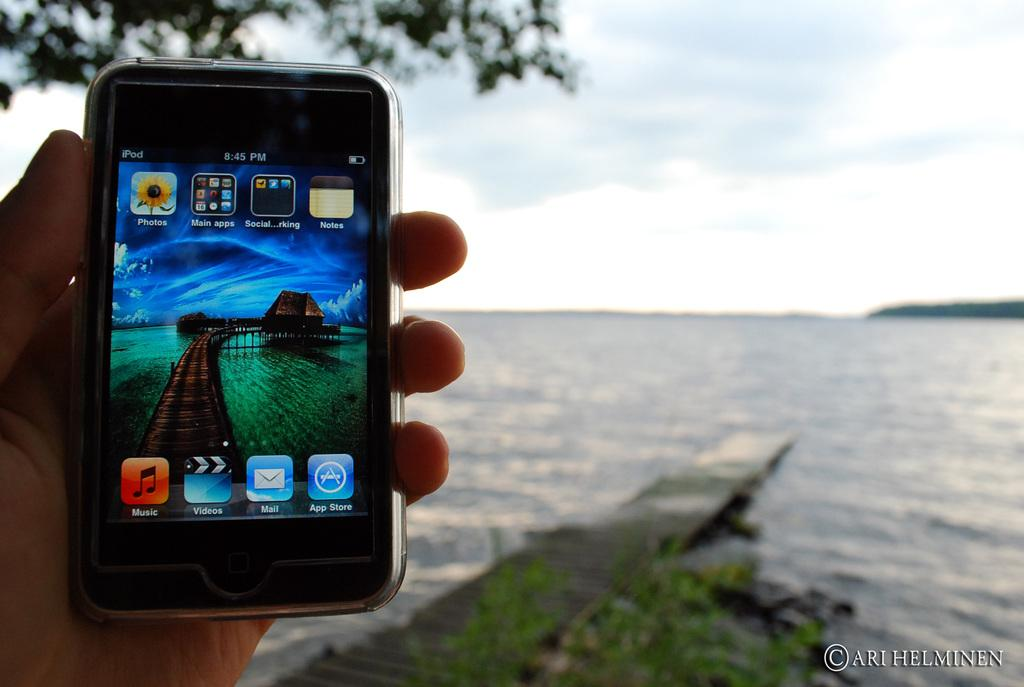<image>
Relay a brief, clear account of the picture shown. A phone screen displays the time as eight forty five pm. 